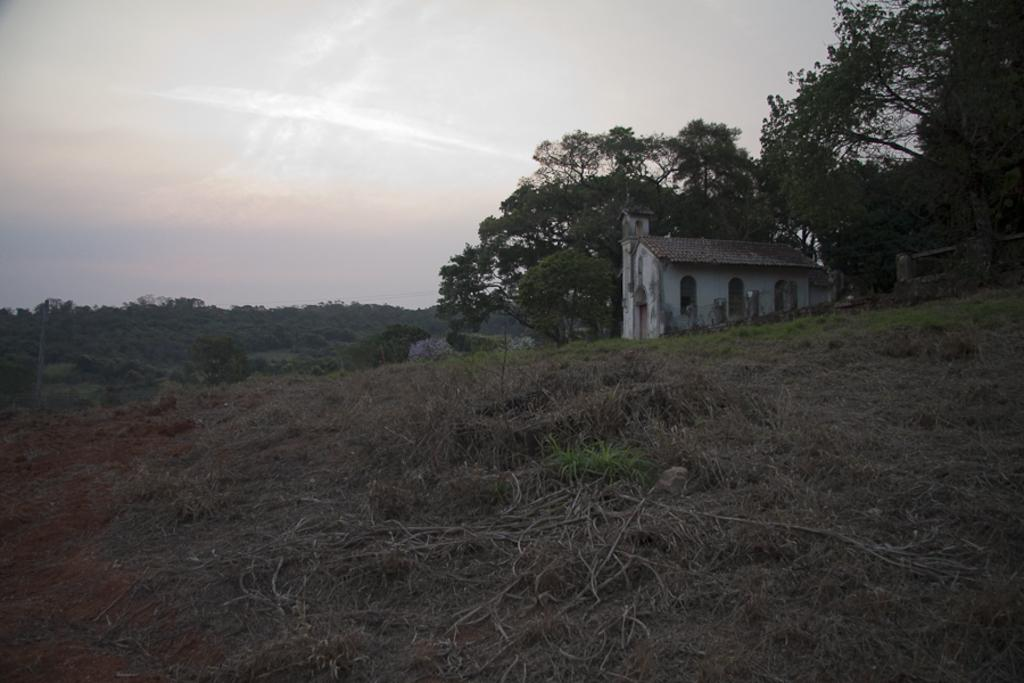What type of vegetation is present in the image? There is dry grass in the image. What other natural elements can be seen in the image? There are trees in the image. What type of structure is visible in the image? There is a house in the image. What is visible at the top of the image? The sky is visible at the top of the image. How many eggs are being drawn with chalk in the image? There are no eggs or chalk present in the image. What type of plane can be seen flying in the image? There is no plane visible in the image. 